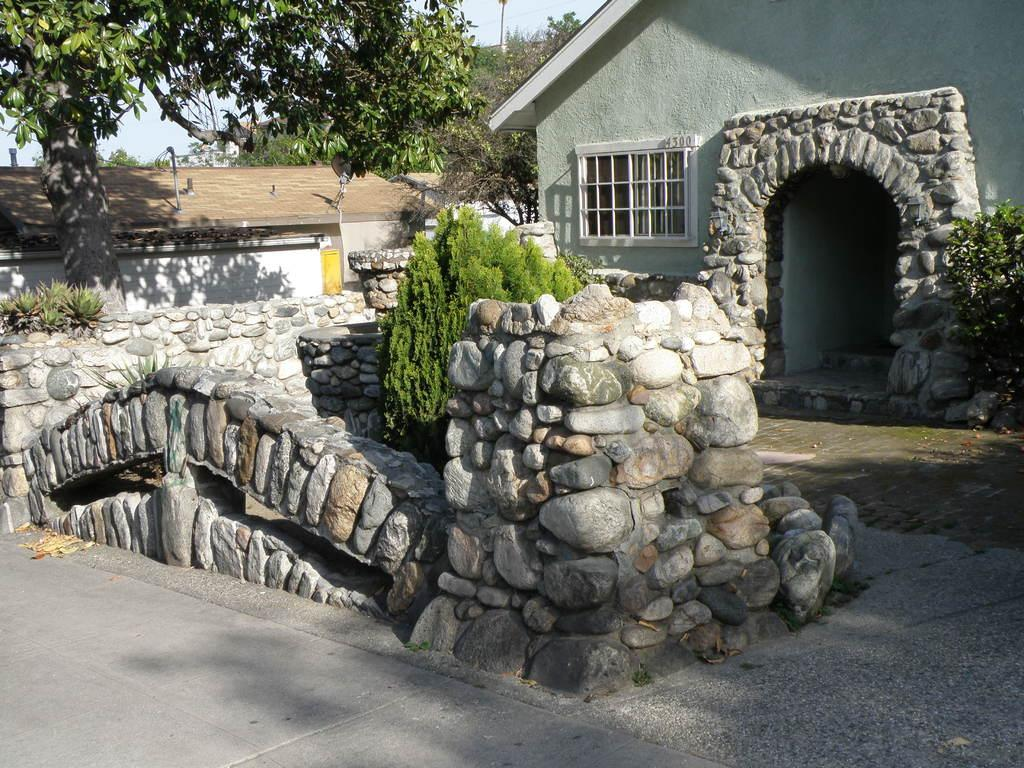What type of structures can be seen in the image? There are buildings in the image. What other natural elements are present in the image? There are trees and plants in the image. What is the surface that vehicles might travel on in the image? There is a road visible at the bottom of the image. What is visible in the upper part of the image? The sky is visible at the top of the image. What type of cheese is being served to the queen in the image? There is no cheese or queen present in the image. Where is the spot where the animals gather in the image? There are no animals or spots visible in the image. 